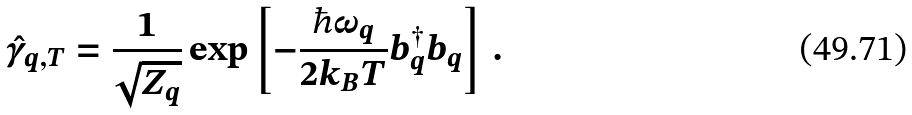Convert formula to latex. <formula><loc_0><loc_0><loc_500><loc_500>\hat { \gamma } _ { q , T } = \frac { 1 } { { \sqrt { Z _ { q } } } } \exp \left [ { - \frac { \hbar { \omega } _ { q } } { 2 k _ { B } T } b _ { q } ^ { \dagger } b _ { q } } \right ] \, .</formula> 